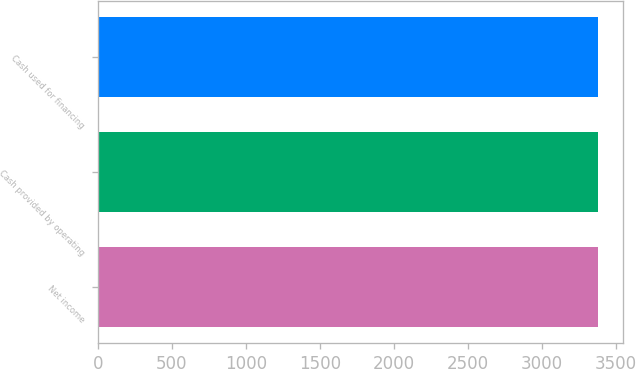<chart> <loc_0><loc_0><loc_500><loc_500><bar_chart><fcel>Net income<fcel>Cash provided by operating<fcel>Cash used for financing<nl><fcel>3374<fcel>3374.1<fcel>3374.2<nl></chart> 